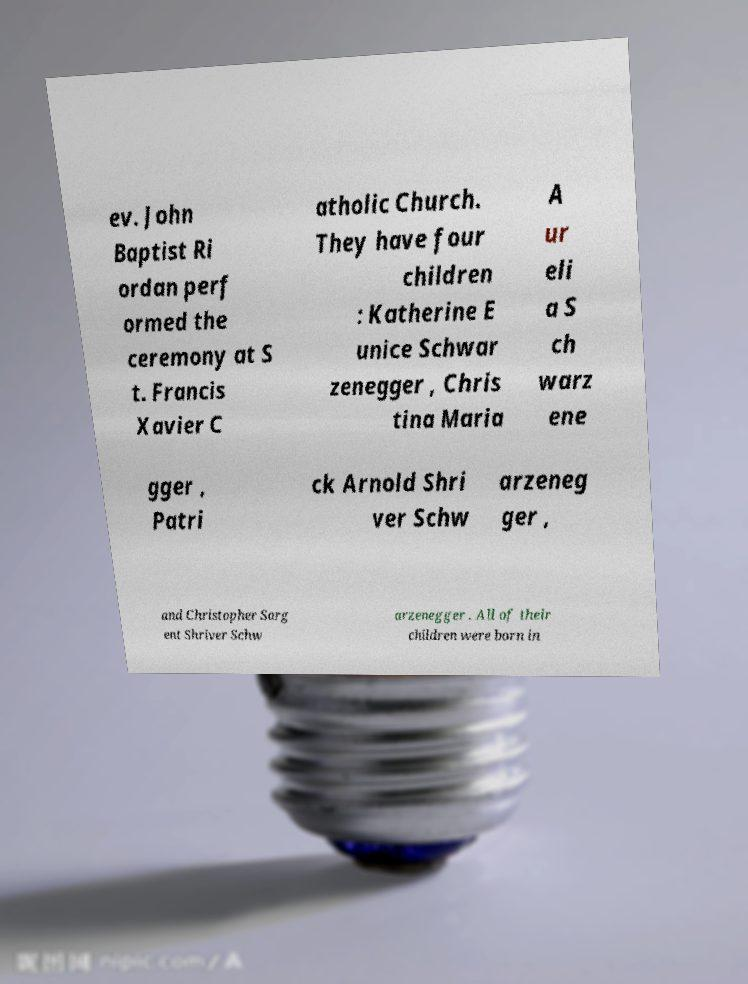There's text embedded in this image that I need extracted. Can you transcribe it verbatim? ev. John Baptist Ri ordan perf ormed the ceremony at S t. Francis Xavier C atholic Church. They have four children : Katherine E unice Schwar zenegger , Chris tina Maria A ur eli a S ch warz ene gger , Patri ck Arnold Shri ver Schw arzeneg ger , and Christopher Sarg ent Shriver Schw arzenegger . All of their children were born in 